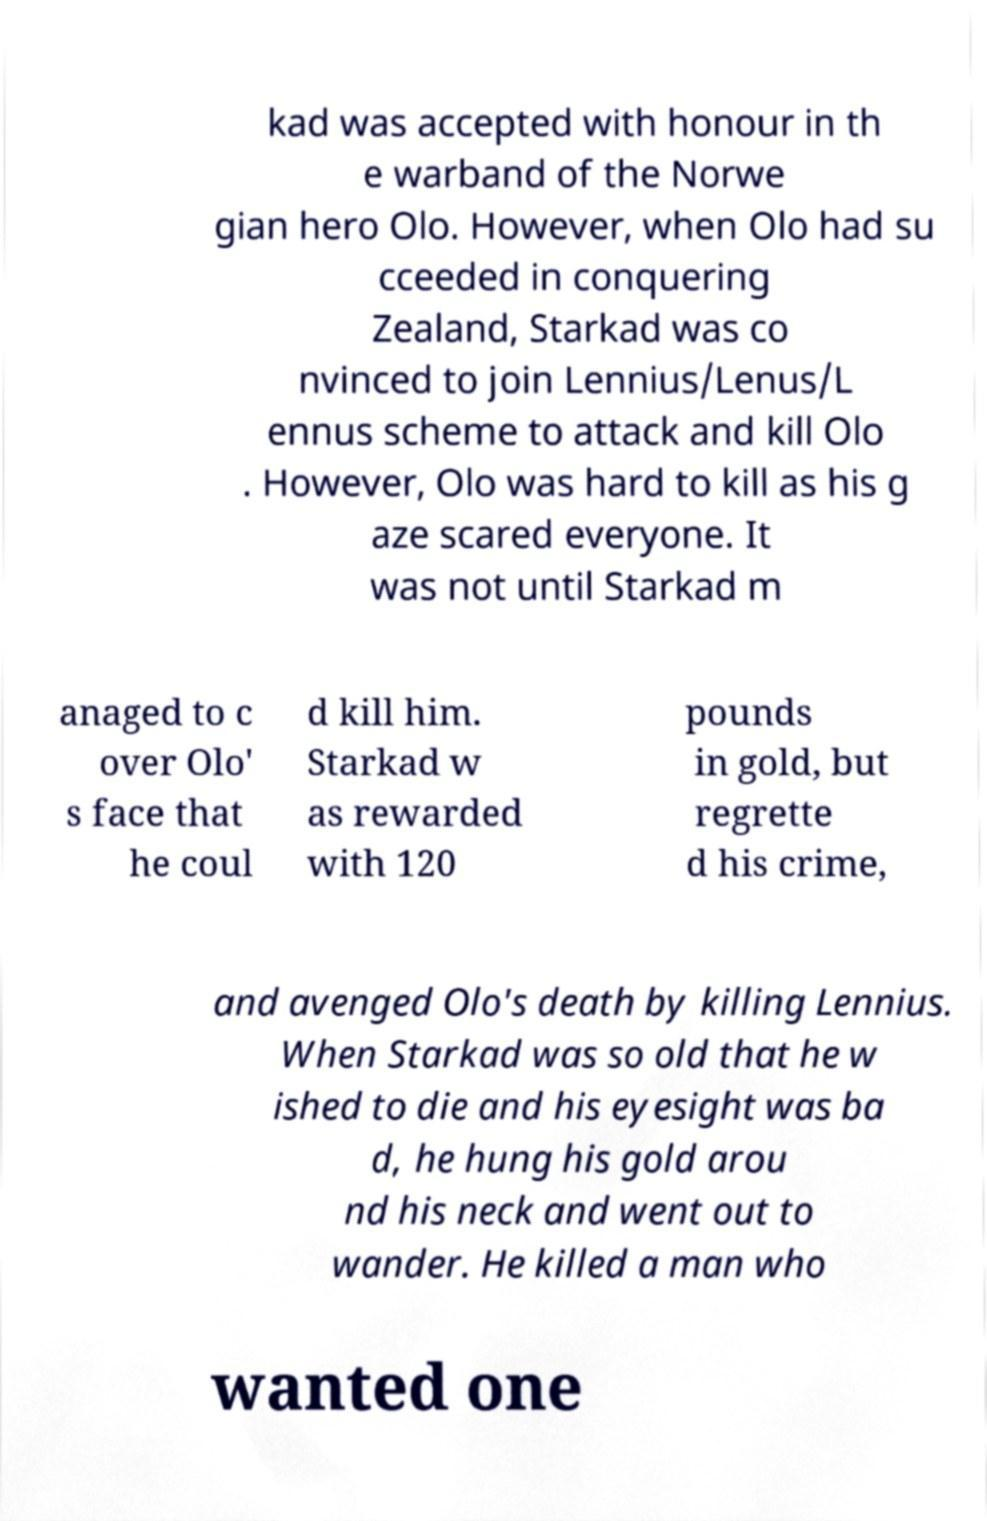Could you assist in decoding the text presented in this image and type it out clearly? kad was accepted with honour in th e warband of the Norwe gian hero Olo. However, when Olo had su cceeded in conquering Zealand, Starkad was co nvinced to join Lennius/Lenus/L ennus scheme to attack and kill Olo . However, Olo was hard to kill as his g aze scared everyone. It was not until Starkad m anaged to c over Olo' s face that he coul d kill him. Starkad w as rewarded with 120 pounds in gold, but regrette d his crime, and avenged Olo's death by killing Lennius. When Starkad was so old that he w ished to die and his eyesight was ba d, he hung his gold arou nd his neck and went out to wander. He killed a man who wanted one 